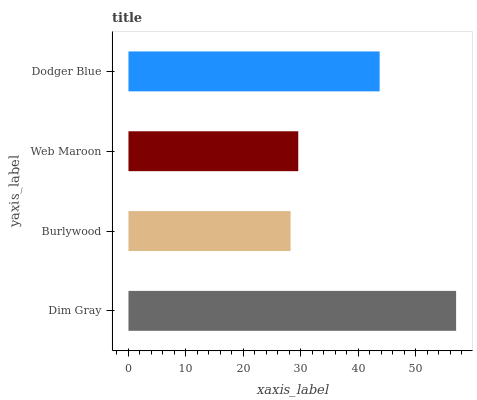Is Burlywood the minimum?
Answer yes or no. Yes. Is Dim Gray the maximum?
Answer yes or no. Yes. Is Web Maroon the minimum?
Answer yes or no. No. Is Web Maroon the maximum?
Answer yes or no. No. Is Web Maroon greater than Burlywood?
Answer yes or no. Yes. Is Burlywood less than Web Maroon?
Answer yes or no. Yes. Is Burlywood greater than Web Maroon?
Answer yes or no. No. Is Web Maroon less than Burlywood?
Answer yes or no. No. Is Dodger Blue the high median?
Answer yes or no. Yes. Is Web Maroon the low median?
Answer yes or no. Yes. Is Web Maroon the high median?
Answer yes or no. No. Is Dodger Blue the low median?
Answer yes or no. No. 